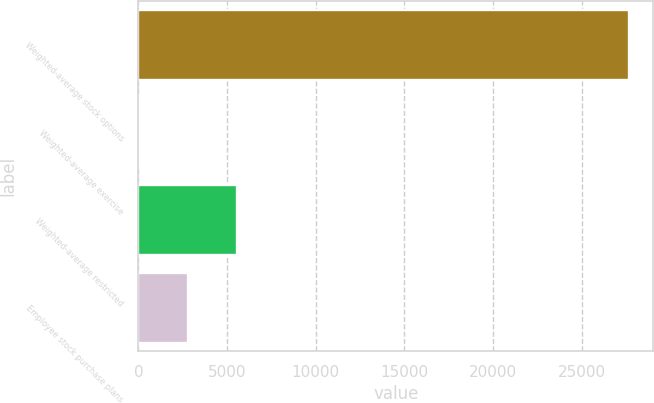Convert chart. <chart><loc_0><loc_0><loc_500><loc_500><bar_chart><fcel>Weighted-average stock options<fcel>Weighted-average exercise<fcel>Weighted-average restricted<fcel>Employee stock purchase plans<nl><fcel>27636<fcel>27.68<fcel>5549.34<fcel>2788.51<nl></chart> 